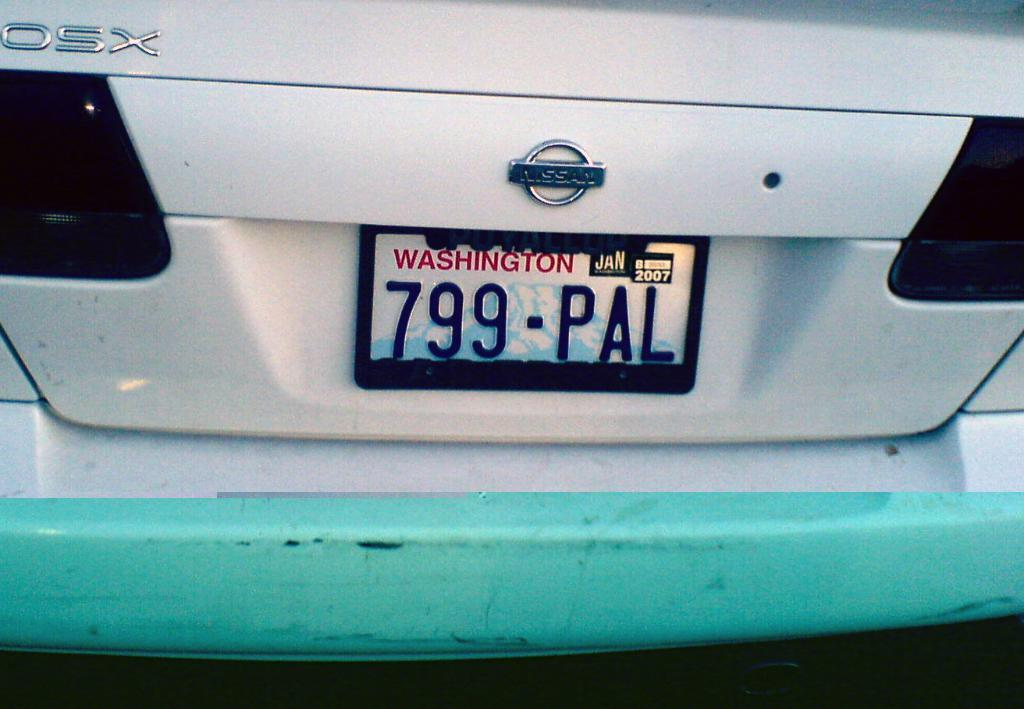<image>
Provide a brief description of the given image. A Nissan car with a Washington license plate on it. 